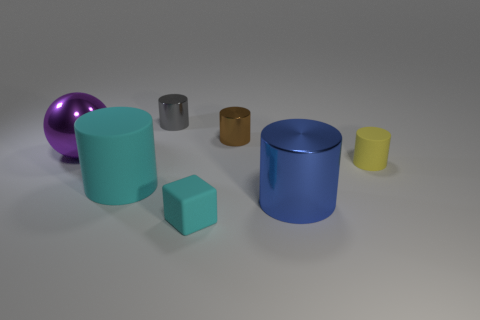Subtract 1 cylinders. How many cylinders are left? 4 Add 2 yellow cubes. How many objects exist? 9 Subtract all small brown cylinders. How many cylinders are left? 4 Subtract all blue cylinders. How many cylinders are left? 4 Subtract all blocks. How many objects are left? 6 Subtract all purple cylinders. Subtract all blue blocks. How many cylinders are left? 5 Add 4 large green metal cubes. How many large green metal cubes exist? 4 Subtract 0 red cylinders. How many objects are left? 7 Subtract all big blue objects. Subtract all small metallic cylinders. How many objects are left? 4 Add 3 big purple objects. How many big purple objects are left? 4 